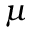Convert formula to latex. <formula><loc_0><loc_0><loc_500><loc_500>\mu</formula> 